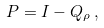Convert formula to latex. <formula><loc_0><loc_0><loc_500><loc_500>P = I - Q _ { \rho } \, ,</formula> 